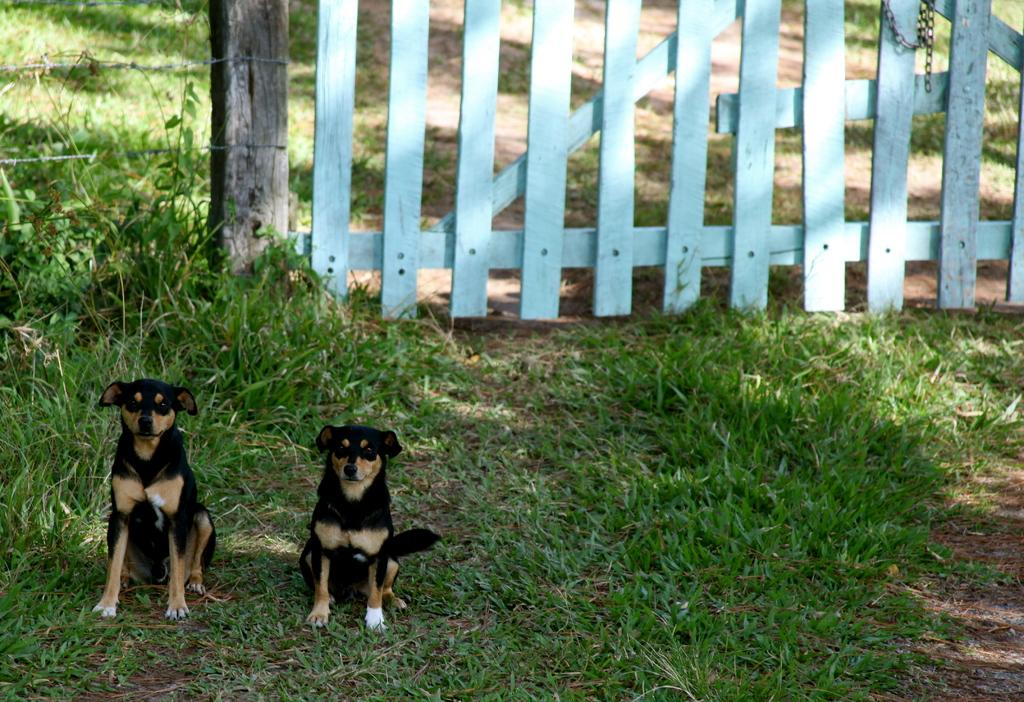How many dogs are in the image? There are two dogs in the image. What is located behind the dogs? There is a fence behind the dogs. What type of surface is at the bottom of the image? Grass is present at the bottom of the image. What room are the dogs in, according to the image? The image does not show the dogs in a room; it is an outdoor scene with a fence and grass. 